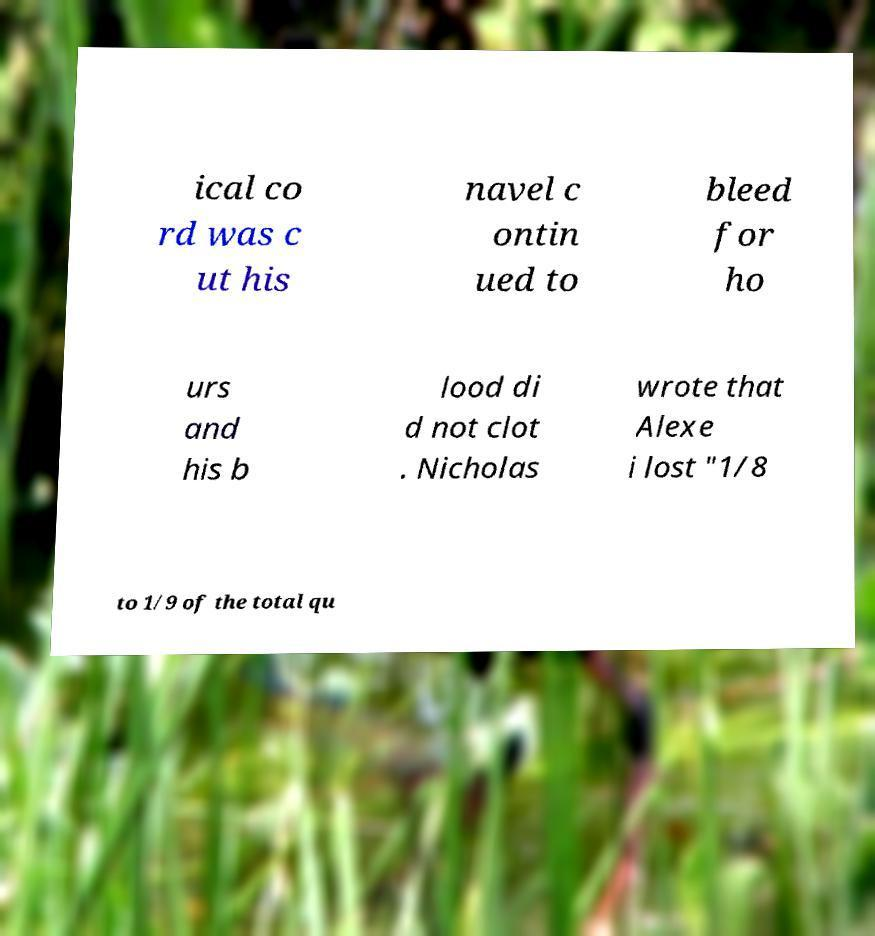Please read and relay the text visible in this image. What does it say? ical co rd was c ut his navel c ontin ued to bleed for ho urs and his b lood di d not clot . Nicholas wrote that Alexe i lost "1/8 to 1/9 of the total qu 